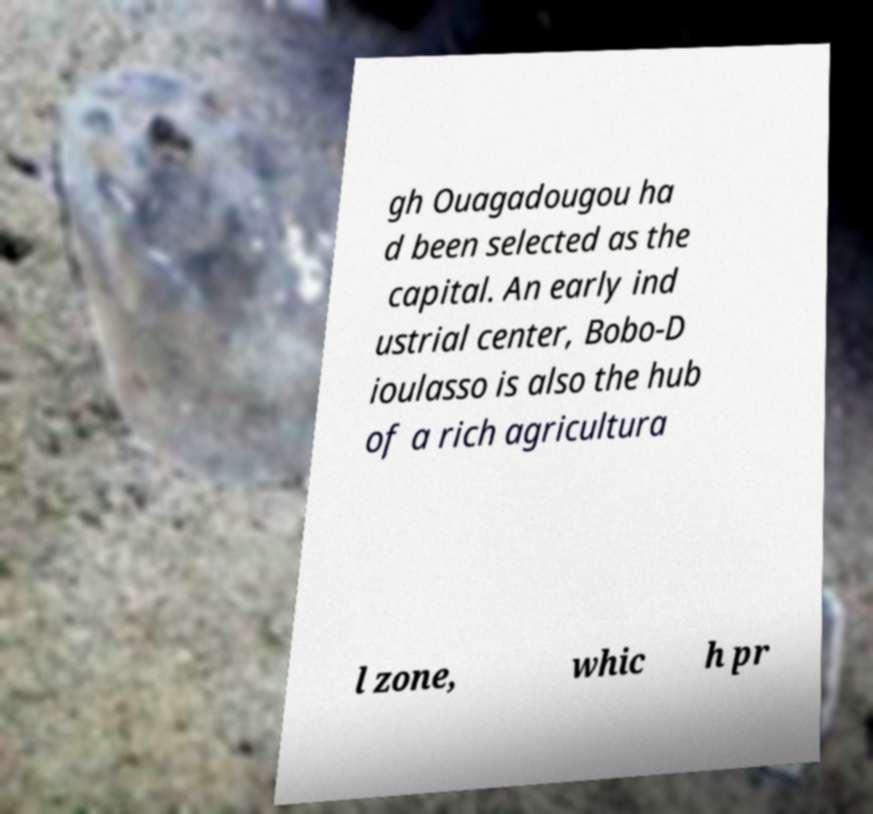Can you accurately transcribe the text from the provided image for me? gh Ouagadougou ha d been selected as the capital. An early ind ustrial center, Bobo-D ioulasso is also the hub of a rich agricultura l zone, whic h pr 